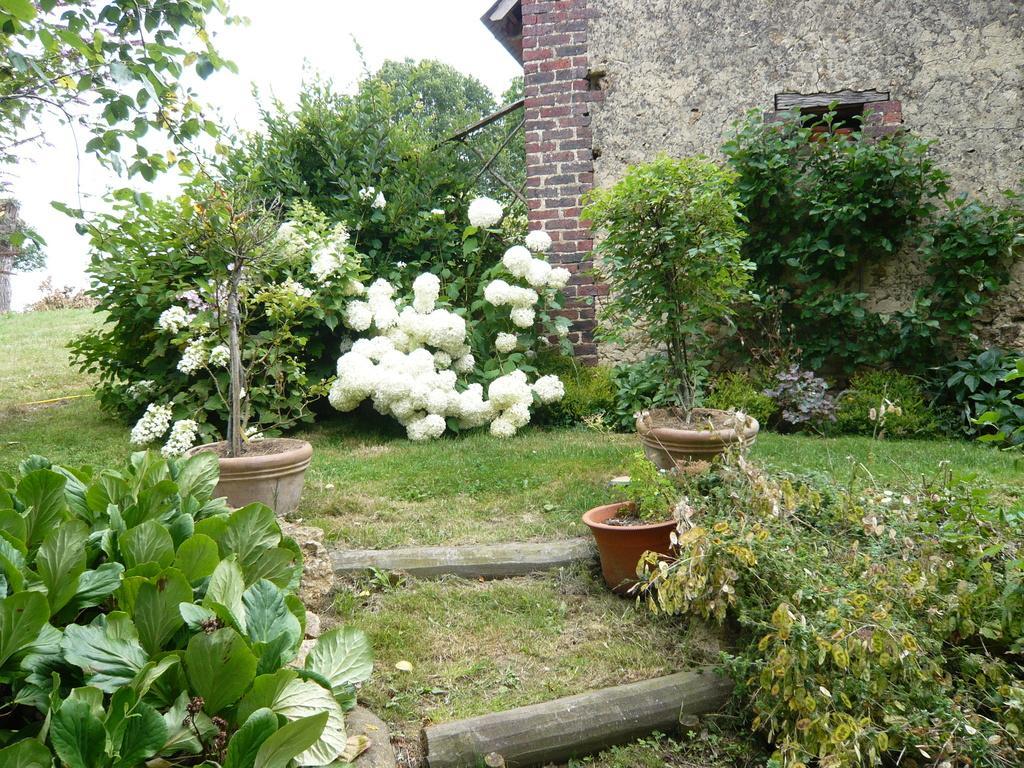In one or two sentences, can you explain what this image depicts? In this picture we can observe some plants on the land. There is some grass. We can observe some plant pots. There is a house on the right side. In the background there are trees and a sky. 